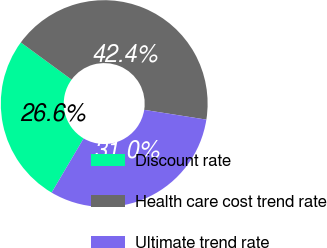Convert chart to OTSL. <chart><loc_0><loc_0><loc_500><loc_500><pie_chart><fcel>Discount rate<fcel>Health care cost trend rate<fcel>Ultimate trend rate<nl><fcel>26.58%<fcel>42.41%<fcel>31.01%<nl></chart> 